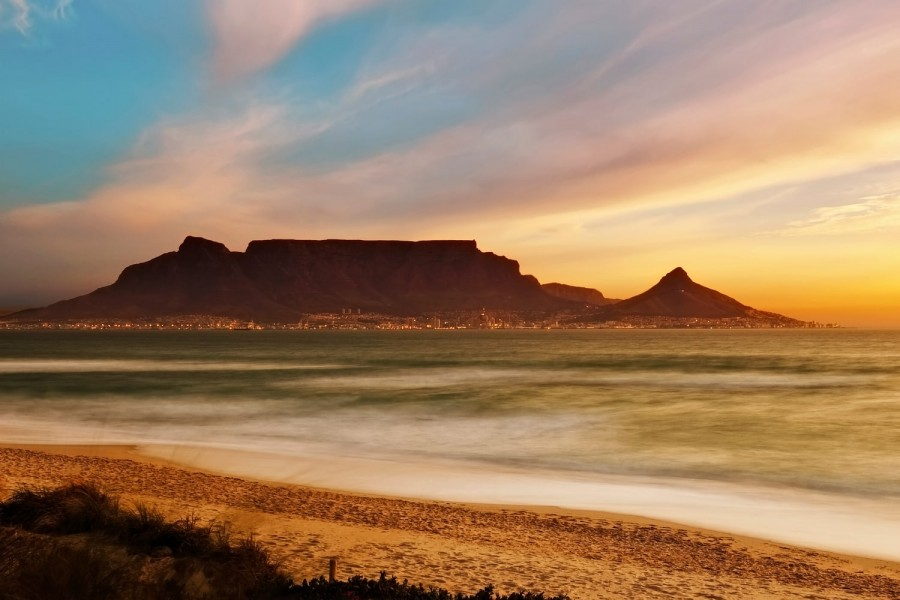Imagine visiting this place on a summer evening. Describe the atmosphere and sensory experiences. Visiting this beach on a summer evening, you would be enveloped by the warm, golden hues of the setting sun casting long shadows across the sand. The air would be filled with the gentle sound of waves lightly breaking on the shore, a rhythmic lullaby complemented by occasional laughter and chatter of visitors enjoying the picturesque scene. The scent of salty ocean air mixed with a faint whiff of barbecues from nearby gatherings would tantalize your senses. As the sun dips lower, the sky transforms into a canvas of oranges, pinks, and purples, with city lights beginning to twinkle at the foot of Table Mountain. Walking along the beach, you feel the soft, cool sand under your feet and occasionally come across a seashell or two, reminders of the ocean's treasures. Everything around exudes a feeling of calm, beauty, and a touch of awe. 